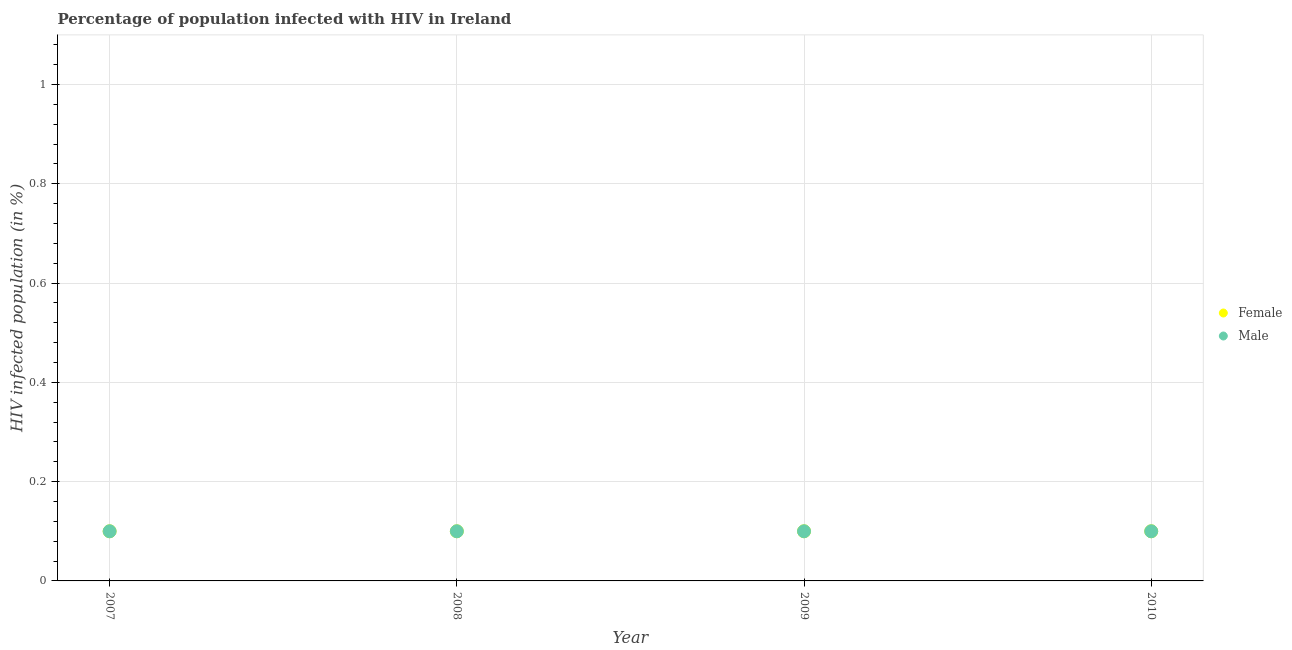Is the number of dotlines equal to the number of legend labels?
Your response must be concise. Yes. What is the percentage of males who are infected with hiv in 2009?
Offer a very short reply. 0.1. Across all years, what is the minimum percentage of females who are infected with hiv?
Offer a very short reply. 0.1. In which year was the percentage of females who are infected with hiv minimum?
Keep it short and to the point. 2007. What is the total percentage of females who are infected with hiv in the graph?
Provide a short and direct response. 0.4. What is the difference between the percentage of males who are infected with hiv in 2008 and that in 2010?
Provide a succinct answer. 0. What is the difference between the percentage of females who are infected with hiv in 2010 and the percentage of males who are infected with hiv in 2009?
Your response must be concise. 0. What is the average percentage of males who are infected with hiv per year?
Provide a succinct answer. 0.1. In the year 2010, what is the difference between the percentage of males who are infected with hiv and percentage of females who are infected with hiv?
Keep it short and to the point. 0. In how many years, is the percentage of males who are infected with hiv greater than 1 %?
Offer a terse response. 0. What is the ratio of the percentage of males who are infected with hiv in 2007 to that in 2008?
Your response must be concise. 1. Does the percentage of males who are infected with hiv monotonically increase over the years?
Your answer should be very brief. No. Is the percentage of males who are infected with hiv strictly greater than the percentage of females who are infected with hiv over the years?
Provide a succinct answer. No. Is the percentage of females who are infected with hiv strictly less than the percentage of males who are infected with hiv over the years?
Offer a very short reply. No. What is the difference between two consecutive major ticks on the Y-axis?
Ensure brevity in your answer.  0.2. Are the values on the major ticks of Y-axis written in scientific E-notation?
Your response must be concise. No. Does the graph contain grids?
Ensure brevity in your answer.  Yes. Where does the legend appear in the graph?
Make the answer very short. Center right. What is the title of the graph?
Ensure brevity in your answer.  Percentage of population infected with HIV in Ireland. What is the label or title of the Y-axis?
Your response must be concise. HIV infected population (in %). What is the HIV infected population (in %) of Female in 2007?
Offer a terse response. 0.1. What is the HIV infected population (in %) of Male in 2007?
Your response must be concise. 0.1. What is the HIV infected population (in %) in Male in 2010?
Your response must be concise. 0.1. Across all years, what is the maximum HIV infected population (in %) in Female?
Make the answer very short. 0.1. Across all years, what is the maximum HIV infected population (in %) of Male?
Ensure brevity in your answer.  0.1. Across all years, what is the minimum HIV infected population (in %) in Female?
Keep it short and to the point. 0.1. What is the total HIV infected population (in %) of Male in the graph?
Keep it short and to the point. 0.4. What is the difference between the HIV infected population (in %) in Male in 2007 and that in 2008?
Provide a short and direct response. 0. What is the difference between the HIV infected population (in %) of Female in 2007 and that in 2009?
Your answer should be very brief. 0. What is the difference between the HIV infected population (in %) of Male in 2007 and that in 2010?
Your answer should be very brief. 0. What is the difference between the HIV infected population (in %) in Female in 2008 and that in 2009?
Give a very brief answer. 0. What is the difference between the HIV infected population (in %) of Male in 2008 and that in 2010?
Offer a very short reply. 0. What is the difference between the HIV infected population (in %) of Female in 2007 and the HIV infected population (in %) of Male in 2008?
Make the answer very short. 0. What is the difference between the HIV infected population (in %) of Female in 2007 and the HIV infected population (in %) of Male in 2009?
Your answer should be compact. 0. What is the difference between the HIV infected population (in %) in Female in 2008 and the HIV infected population (in %) in Male in 2009?
Provide a succinct answer. 0. In the year 2008, what is the difference between the HIV infected population (in %) in Female and HIV infected population (in %) in Male?
Your response must be concise. 0. In the year 2010, what is the difference between the HIV infected population (in %) in Female and HIV infected population (in %) in Male?
Make the answer very short. 0. What is the ratio of the HIV infected population (in %) of Female in 2007 to that in 2008?
Provide a succinct answer. 1. What is the ratio of the HIV infected population (in %) in Female in 2007 to that in 2010?
Provide a short and direct response. 1. What is the ratio of the HIV infected population (in %) in Male in 2007 to that in 2010?
Offer a very short reply. 1. What is the ratio of the HIV infected population (in %) of Female in 2008 to that in 2009?
Your answer should be very brief. 1. What is the ratio of the HIV infected population (in %) in Male in 2008 to that in 2010?
Offer a very short reply. 1. What is the ratio of the HIV infected population (in %) in Female in 2009 to that in 2010?
Keep it short and to the point. 1. What is the ratio of the HIV infected population (in %) of Male in 2009 to that in 2010?
Offer a terse response. 1. 